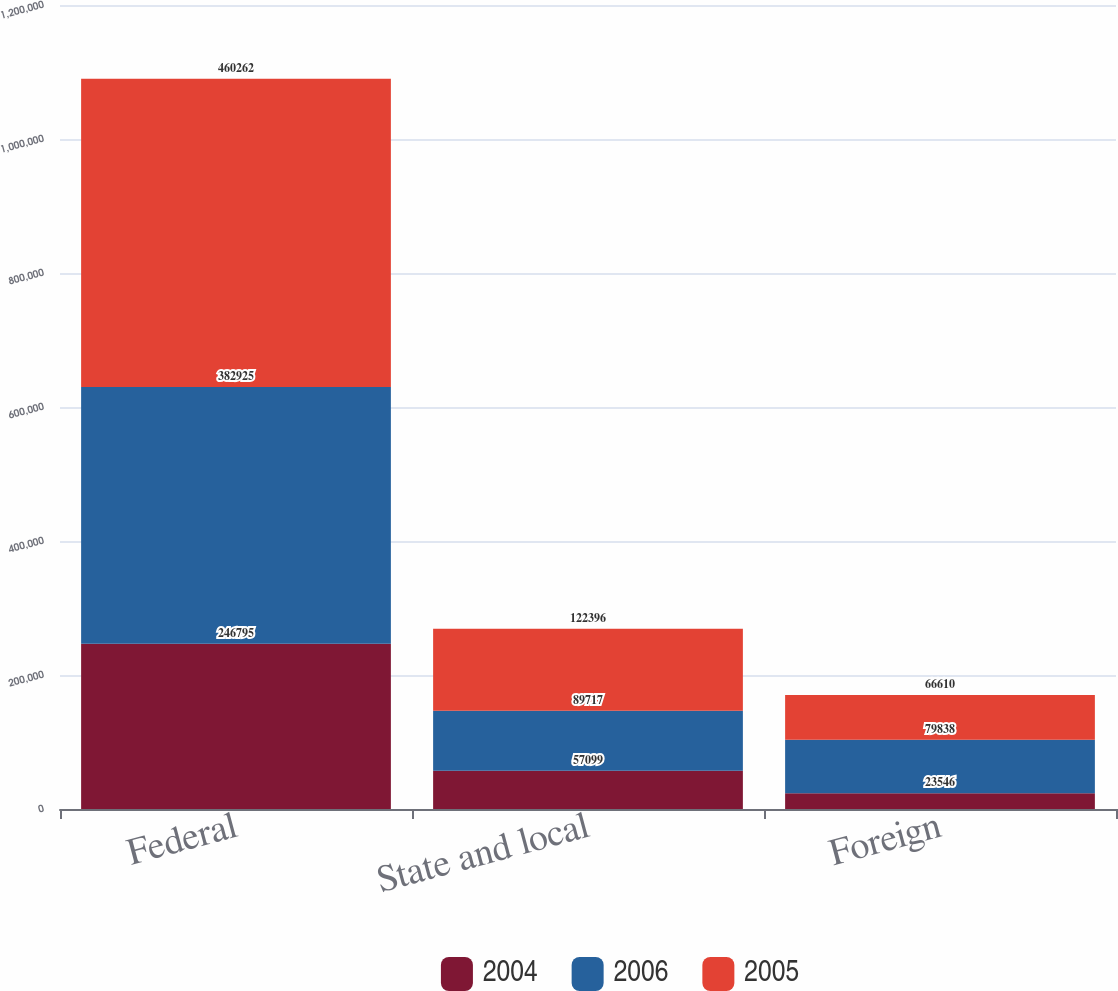Convert chart to OTSL. <chart><loc_0><loc_0><loc_500><loc_500><stacked_bar_chart><ecel><fcel>Federal<fcel>State and local<fcel>Foreign<nl><fcel>2004<fcel>246795<fcel>57099<fcel>23546<nl><fcel>2006<fcel>382925<fcel>89717<fcel>79838<nl><fcel>2005<fcel>460262<fcel>122396<fcel>66610<nl></chart> 